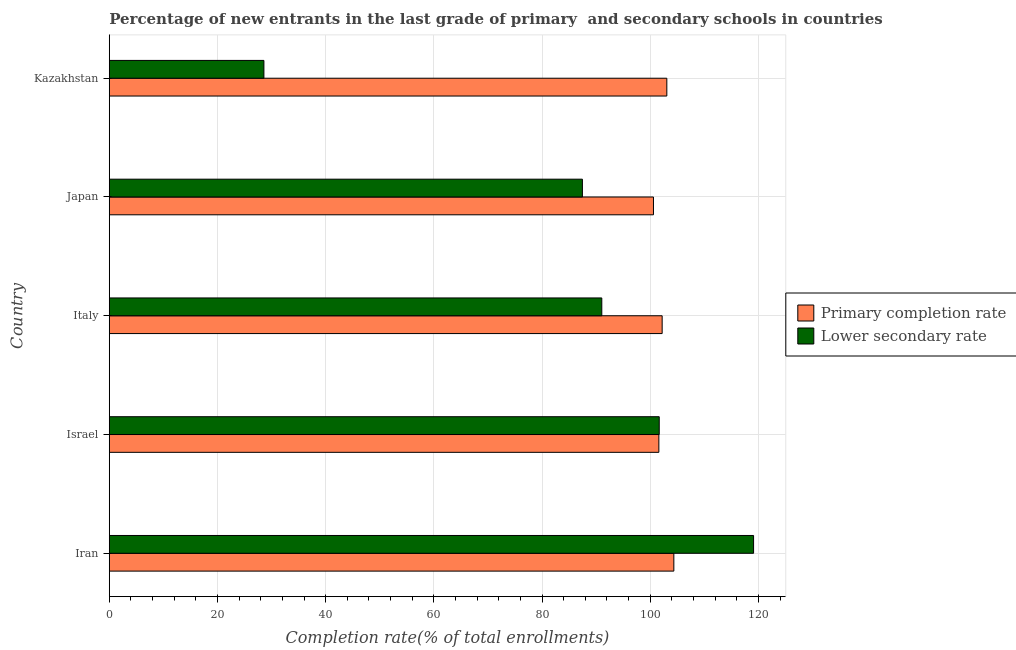How many different coloured bars are there?
Ensure brevity in your answer.  2. Are the number of bars per tick equal to the number of legend labels?
Your response must be concise. Yes. How many bars are there on the 1st tick from the top?
Offer a terse response. 2. What is the completion rate in secondary schools in Iran?
Your answer should be compact. 119.11. Across all countries, what is the maximum completion rate in secondary schools?
Provide a succinct answer. 119.11. Across all countries, what is the minimum completion rate in primary schools?
Give a very brief answer. 100.6. In which country was the completion rate in primary schools maximum?
Provide a succinct answer. Iran. In which country was the completion rate in secondary schools minimum?
Your answer should be compact. Kazakhstan. What is the total completion rate in secondary schools in the graph?
Your answer should be compact. 427.87. What is the difference between the completion rate in secondary schools in Iran and that in Kazakhstan?
Your response must be concise. 90.52. What is the difference between the completion rate in primary schools in Iran and the completion rate in secondary schools in Kazakhstan?
Your answer should be very brief. 75.78. What is the average completion rate in primary schools per country?
Make the answer very short. 102.37. What is the difference between the completion rate in primary schools and completion rate in secondary schools in Kazakhstan?
Ensure brevity in your answer.  74.48. In how many countries, is the completion rate in secondary schools greater than 84 %?
Ensure brevity in your answer.  4. Is the completion rate in primary schools in Israel less than that in Kazakhstan?
Your response must be concise. Yes. Is the difference between the completion rate in primary schools in Iran and Israel greater than the difference between the completion rate in secondary schools in Iran and Israel?
Ensure brevity in your answer.  No. What is the difference between the highest and the second highest completion rate in primary schools?
Offer a terse response. 1.3. What is the difference between the highest and the lowest completion rate in secondary schools?
Your answer should be very brief. 90.52. In how many countries, is the completion rate in primary schools greater than the average completion rate in primary schools taken over all countries?
Offer a terse response. 2. What does the 2nd bar from the top in Japan represents?
Make the answer very short. Primary completion rate. What does the 2nd bar from the bottom in Japan represents?
Give a very brief answer. Lower secondary rate. How many bars are there?
Offer a very short reply. 10. How many countries are there in the graph?
Keep it short and to the point. 5. How many legend labels are there?
Give a very brief answer. 2. How are the legend labels stacked?
Ensure brevity in your answer.  Vertical. What is the title of the graph?
Your response must be concise. Percentage of new entrants in the last grade of primary  and secondary schools in countries. What is the label or title of the X-axis?
Offer a very short reply. Completion rate(% of total enrollments). What is the label or title of the Y-axis?
Keep it short and to the point. Country. What is the Completion rate(% of total enrollments) in Primary completion rate in Iran?
Your response must be concise. 104.37. What is the Completion rate(% of total enrollments) of Lower secondary rate in Iran?
Provide a succinct answer. 119.11. What is the Completion rate(% of total enrollments) in Primary completion rate in Israel?
Your response must be concise. 101.6. What is the Completion rate(% of total enrollments) of Lower secondary rate in Israel?
Your response must be concise. 101.67. What is the Completion rate(% of total enrollments) in Primary completion rate in Italy?
Give a very brief answer. 102.21. What is the Completion rate(% of total enrollments) of Lower secondary rate in Italy?
Your response must be concise. 91.05. What is the Completion rate(% of total enrollments) of Primary completion rate in Japan?
Make the answer very short. 100.6. What is the Completion rate(% of total enrollments) of Lower secondary rate in Japan?
Offer a very short reply. 87.46. What is the Completion rate(% of total enrollments) of Primary completion rate in Kazakhstan?
Your answer should be very brief. 103.07. What is the Completion rate(% of total enrollments) of Lower secondary rate in Kazakhstan?
Offer a terse response. 28.59. Across all countries, what is the maximum Completion rate(% of total enrollments) in Primary completion rate?
Offer a terse response. 104.37. Across all countries, what is the maximum Completion rate(% of total enrollments) of Lower secondary rate?
Give a very brief answer. 119.11. Across all countries, what is the minimum Completion rate(% of total enrollments) in Primary completion rate?
Keep it short and to the point. 100.6. Across all countries, what is the minimum Completion rate(% of total enrollments) of Lower secondary rate?
Provide a short and direct response. 28.59. What is the total Completion rate(% of total enrollments) in Primary completion rate in the graph?
Provide a succinct answer. 511.84. What is the total Completion rate(% of total enrollments) of Lower secondary rate in the graph?
Give a very brief answer. 427.87. What is the difference between the Completion rate(% of total enrollments) of Primary completion rate in Iran and that in Israel?
Ensure brevity in your answer.  2.77. What is the difference between the Completion rate(% of total enrollments) in Lower secondary rate in Iran and that in Israel?
Your answer should be compact. 17.44. What is the difference between the Completion rate(% of total enrollments) of Primary completion rate in Iran and that in Italy?
Make the answer very short. 2.16. What is the difference between the Completion rate(% of total enrollments) in Lower secondary rate in Iran and that in Italy?
Offer a terse response. 28.06. What is the difference between the Completion rate(% of total enrollments) of Primary completion rate in Iran and that in Japan?
Keep it short and to the point. 3.77. What is the difference between the Completion rate(% of total enrollments) of Lower secondary rate in Iran and that in Japan?
Offer a very short reply. 31.64. What is the difference between the Completion rate(% of total enrollments) in Primary completion rate in Iran and that in Kazakhstan?
Your answer should be compact. 1.3. What is the difference between the Completion rate(% of total enrollments) of Lower secondary rate in Iran and that in Kazakhstan?
Offer a terse response. 90.52. What is the difference between the Completion rate(% of total enrollments) in Primary completion rate in Israel and that in Italy?
Provide a succinct answer. -0.61. What is the difference between the Completion rate(% of total enrollments) in Lower secondary rate in Israel and that in Italy?
Keep it short and to the point. 10.62. What is the difference between the Completion rate(% of total enrollments) of Primary completion rate in Israel and that in Japan?
Make the answer very short. 1. What is the difference between the Completion rate(% of total enrollments) in Lower secondary rate in Israel and that in Japan?
Offer a terse response. 14.2. What is the difference between the Completion rate(% of total enrollments) of Primary completion rate in Israel and that in Kazakhstan?
Keep it short and to the point. -1.47. What is the difference between the Completion rate(% of total enrollments) of Lower secondary rate in Israel and that in Kazakhstan?
Make the answer very short. 73.08. What is the difference between the Completion rate(% of total enrollments) in Primary completion rate in Italy and that in Japan?
Offer a very short reply. 1.61. What is the difference between the Completion rate(% of total enrollments) in Lower secondary rate in Italy and that in Japan?
Give a very brief answer. 3.59. What is the difference between the Completion rate(% of total enrollments) in Primary completion rate in Italy and that in Kazakhstan?
Provide a succinct answer. -0.86. What is the difference between the Completion rate(% of total enrollments) in Lower secondary rate in Italy and that in Kazakhstan?
Provide a succinct answer. 62.46. What is the difference between the Completion rate(% of total enrollments) of Primary completion rate in Japan and that in Kazakhstan?
Your answer should be very brief. -2.47. What is the difference between the Completion rate(% of total enrollments) of Lower secondary rate in Japan and that in Kazakhstan?
Offer a very short reply. 58.88. What is the difference between the Completion rate(% of total enrollments) of Primary completion rate in Iran and the Completion rate(% of total enrollments) of Lower secondary rate in Israel?
Provide a short and direct response. 2.7. What is the difference between the Completion rate(% of total enrollments) in Primary completion rate in Iran and the Completion rate(% of total enrollments) in Lower secondary rate in Italy?
Keep it short and to the point. 13.32. What is the difference between the Completion rate(% of total enrollments) in Primary completion rate in Iran and the Completion rate(% of total enrollments) in Lower secondary rate in Japan?
Ensure brevity in your answer.  16.9. What is the difference between the Completion rate(% of total enrollments) of Primary completion rate in Iran and the Completion rate(% of total enrollments) of Lower secondary rate in Kazakhstan?
Your answer should be compact. 75.78. What is the difference between the Completion rate(% of total enrollments) in Primary completion rate in Israel and the Completion rate(% of total enrollments) in Lower secondary rate in Italy?
Ensure brevity in your answer.  10.55. What is the difference between the Completion rate(% of total enrollments) of Primary completion rate in Israel and the Completion rate(% of total enrollments) of Lower secondary rate in Japan?
Offer a very short reply. 14.13. What is the difference between the Completion rate(% of total enrollments) of Primary completion rate in Israel and the Completion rate(% of total enrollments) of Lower secondary rate in Kazakhstan?
Your response must be concise. 73.01. What is the difference between the Completion rate(% of total enrollments) in Primary completion rate in Italy and the Completion rate(% of total enrollments) in Lower secondary rate in Japan?
Provide a succinct answer. 14.75. What is the difference between the Completion rate(% of total enrollments) of Primary completion rate in Italy and the Completion rate(% of total enrollments) of Lower secondary rate in Kazakhstan?
Offer a very short reply. 73.62. What is the difference between the Completion rate(% of total enrollments) in Primary completion rate in Japan and the Completion rate(% of total enrollments) in Lower secondary rate in Kazakhstan?
Keep it short and to the point. 72.01. What is the average Completion rate(% of total enrollments) of Primary completion rate per country?
Ensure brevity in your answer.  102.37. What is the average Completion rate(% of total enrollments) in Lower secondary rate per country?
Ensure brevity in your answer.  85.57. What is the difference between the Completion rate(% of total enrollments) of Primary completion rate and Completion rate(% of total enrollments) of Lower secondary rate in Iran?
Offer a terse response. -14.74. What is the difference between the Completion rate(% of total enrollments) of Primary completion rate and Completion rate(% of total enrollments) of Lower secondary rate in Israel?
Offer a terse response. -0.07. What is the difference between the Completion rate(% of total enrollments) in Primary completion rate and Completion rate(% of total enrollments) in Lower secondary rate in Italy?
Make the answer very short. 11.16. What is the difference between the Completion rate(% of total enrollments) in Primary completion rate and Completion rate(% of total enrollments) in Lower secondary rate in Japan?
Make the answer very short. 13.14. What is the difference between the Completion rate(% of total enrollments) of Primary completion rate and Completion rate(% of total enrollments) of Lower secondary rate in Kazakhstan?
Provide a succinct answer. 74.48. What is the ratio of the Completion rate(% of total enrollments) of Primary completion rate in Iran to that in Israel?
Provide a short and direct response. 1.03. What is the ratio of the Completion rate(% of total enrollments) in Lower secondary rate in Iran to that in Israel?
Make the answer very short. 1.17. What is the ratio of the Completion rate(% of total enrollments) of Primary completion rate in Iran to that in Italy?
Your answer should be very brief. 1.02. What is the ratio of the Completion rate(% of total enrollments) in Lower secondary rate in Iran to that in Italy?
Make the answer very short. 1.31. What is the ratio of the Completion rate(% of total enrollments) in Primary completion rate in Iran to that in Japan?
Offer a terse response. 1.04. What is the ratio of the Completion rate(% of total enrollments) of Lower secondary rate in Iran to that in Japan?
Provide a short and direct response. 1.36. What is the ratio of the Completion rate(% of total enrollments) in Primary completion rate in Iran to that in Kazakhstan?
Your response must be concise. 1.01. What is the ratio of the Completion rate(% of total enrollments) in Lower secondary rate in Iran to that in Kazakhstan?
Offer a terse response. 4.17. What is the ratio of the Completion rate(% of total enrollments) of Lower secondary rate in Israel to that in Italy?
Your answer should be compact. 1.12. What is the ratio of the Completion rate(% of total enrollments) of Primary completion rate in Israel to that in Japan?
Offer a terse response. 1.01. What is the ratio of the Completion rate(% of total enrollments) in Lower secondary rate in Israel to that in Japan?
Make the answer very short. 1.16. What is the ratio of the Completion rate(% of total enrollments) of Primary completion rate in Israel to that in Kazakhstan?
Your response must be concise. 0.99. What is the ratio of the Completion rate(% of total enrollments) of Lower secondary rate in Israel to that in Kazakhstan?
Your response must be concise. 3.56. What is the ratio of the Completion rate(% of total enrollments) of Primary completion rate in Italy to that in Japan?
Offer a very short reply. 1.02. What is the ratio of the Completion rate(% of total enrollments) in Lower secondary rate in Italy to that in Japan?
Ensure brevity in your answer.  1.04. What is the ratio of the Completion rate(% of total enrollments) of Primary completion rate in Italy to that in Kazakhstan?
Your answer should be compact. 0.99. What is the ratio of the Completion rate(% of total enrollments) of Lower secondary rate in Italy to that in Kazakhstan?
Provide a short and direct response. 3.19. What is the ratio of the Completion rate(% of total enrollments) in Lower secondary rate in Japan to that in Kazakhstan?
Give a very brief answer. 3.06. What is the difference between the highest and the second highest Completion rate(% of total enrollments) in Primary completion rate?
Provide a short and direct response. 1.3. What is the difference between the highest and the second highest Completion rate(% of total enrollments) in Lower secondary rate?
Your answer should be compact. 17.44. What is the difference between the highest and the lowest Completion rate(% of total enrollments) of Primary completion rate?
Offer a very short reply. 3.77. What is the difference between the highest and the lowest Completion rate(% of total enrollments) of Lower secondary rate?
Offer a terse response. 90.52. 